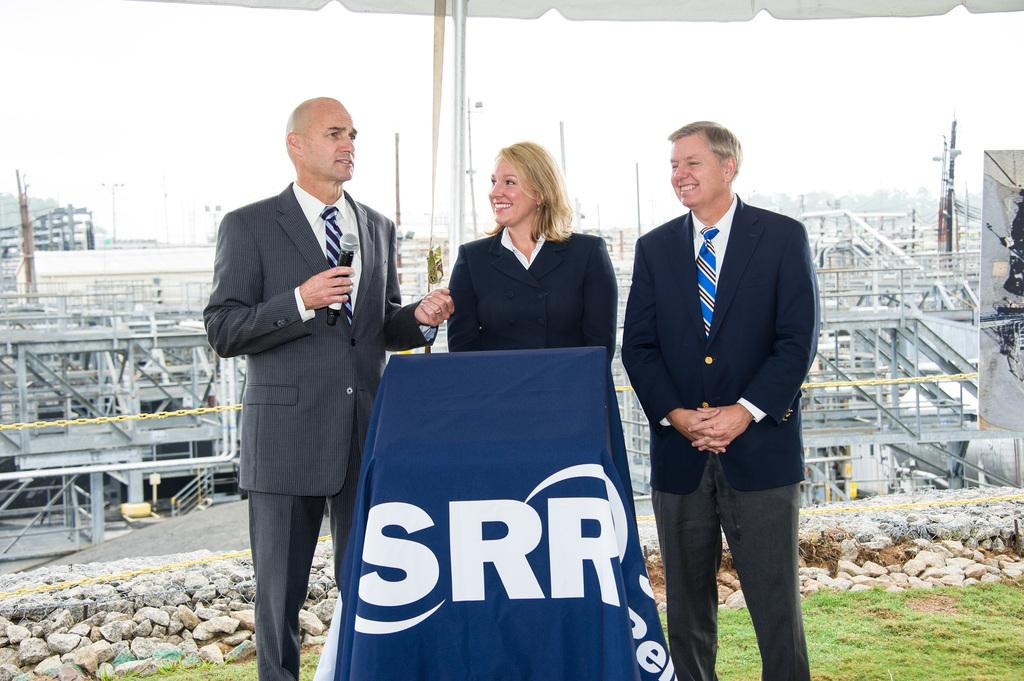<image>
Summarize the visual content of the image. Three people are standing in front of a podium displaying SRR in white letters. 